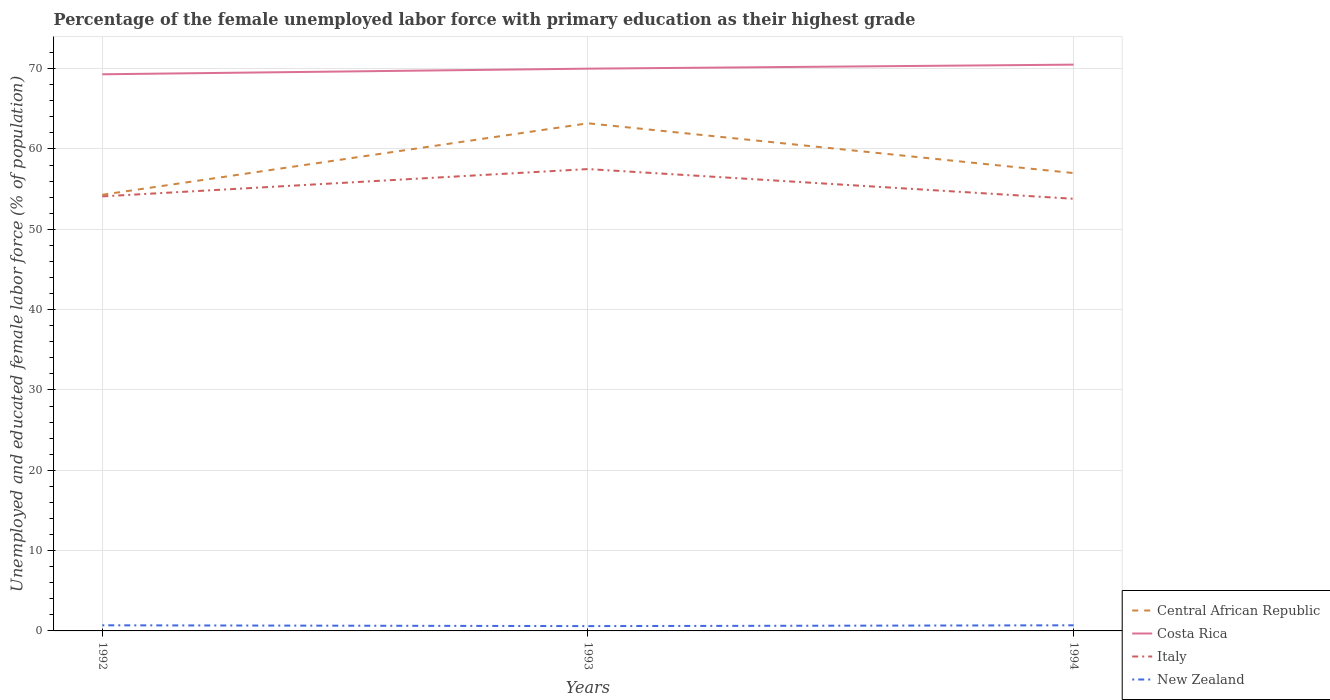How many different coloured lines are there?
Your answer should be very brief. 4. Across all years, what is the maximum percentage of the unemployed female labor force with primary education in Italy?
Your answer should be compact. 53.8. What is the total percentage of the unemployed female labor force with primary education in New Zealand in the graph?
Your answer should be very brief. -0.1. What is the difference between the highest and the second highest percentage of the unemployed female labor force with primary education in Central African Republic?
Your answer should be very brief. 8.9. Is the percentage of the unemployed female labor force with primary education in Central African Republic strictly greater than the percentage of the unemployed female labor force with primary education in New Zealand over the years?
Give a very brief answer. No. How many lines are there?
Your response must be concise. 4. Are the values on the major ticks of Y-axis written in scientific E-notation?
Your answer should be very brief. No. Does the graph contain any zero values?
Provide a short and direct response. No. Where does the legend appear in the graph?
Provide a short and direct response. Bottom right. How many legend labels are there?
Your response must be concise. 4. What is the title of the graph?
Provide a short and direct response. Percentage of the female unemployed labor force with primary education as their highest grade. Does "South Asia" appear as one of the legend labels in the graph?
Provide a succinct answer. No. What is the label or title of the Y-axis?
Your answer should be very brief. Unemployed and educated female labor force (% of population). What is the Unemployed and educated female labor force (% of population) in Central African Republic in 1992?
Your answer should be compact. 54.3. What is the Unemployed and educated female labor force (% of population) of Costa Rica in 1992?
Give a very brief answer. 69.3. What is the Unemployed and educated female labor force (% of population) of Italy in 1992?
Keep it short and to the point. 54.1. What is the Unemployed and educated female labor force (% of population) in New Zealand in 1992?
Ensure brevity in your answer.  0.7. What is the Unemployed and educated female labor force (% of population) in Central African Republic in 1993?
Keep it short and to the point. 63.2. What is the Unemployed and educated female labor force (% of population) in Costa Rica in 1993?
Your answer should be compact. 70. What is the Unemployed and educated female labor force (% of population) of Italy in 1993?
Offer a terse response. 57.5. What is the Unemployed and educated female labor force (% of population) of New Zealand in 1993?
Offer a terse response. 0.6. What is the Unemployed and educated female labor force (% of population) of Costa Rica in 1994?
Provide a succinct answer. 70.5. What is the Unemployed and educated female labor force (% of population) of Italy in 1994?
Your answer should be compact. 53.8. What is the Unemployed and educated female labor force (% of population) in New Zealand in 1994?
Your response must be concise. 0.7. Across all years, what is the maximum Unemployed and educated female labor force (% of population) in Central African Republic?
Offer a terse response. 63.2. Across all years, what is the maximum Unemployed and educated female labor force (% of population) of Costa Rica?
Your response must be concise. 70.5. Across all years, what is the maximum Unemployed and educated female labor force (% of population) in Italy?
Provide a succinct answer. 57.5. Across all years, what is the maximum Unemployed and educated female labor force (% of population) in New Zealand?
Your response must be concise. 0.7. Across all years, what is the minimum Unemployed and educated female labor force (% of population) of Central African Republic?
Give a very brief answer. 54.3. Across all years, what is the minimum Unemployed and educated female labor force (% of population) in Costa Rica?
Your answer should be very brief. 69.3. Across all years, what is the minimum Unemployed and educated female labor force (% of population) of Italy?
Give a very brief answer. 53.8. Across all years, what is the minimum Unemployed and educated female labor force (% of population) in New Zealand?
Offer a terse response. 0.6. What is the total Unemployed and educated female labor force (% of population) of Central African Republic in the graph?
Make the answer very short. 174.5. What is the total Unemployed and educated female labor force (% of population) in Costa Rica in the graph?
Your response must be concise. 209.8. What is the total Unemployed and educated female labor force (% of population) in Italy in the graph?
Give a very brief answer. 165.4. What is the difference between the Unemployed and educated female labor force (% of population) in Italy in 1992 and that in 1993?
Give a very brief answer. -3.4. What is the difference between the Unemployed and educated female labor force (% of population) in New Zealand in 1992 and that in 1993?
Offer a terse response. 0.1. What is the difference between the Unemployed and educated female labor force (% of population) in Central African Republic in 1993 and that in 1994?
Your answer should be very brief. 6.2. What is the difference between the Unemployed and educated female labor force (% of population) of Italy in 1993 and that in 1994?
Offer a very short reply. 3.7. What is the difference between the Unemployed and educated female labor force (% of population) in Central African Republic in 1992 and the Unemployed and educated female labor force (% of population) in Costa Rica in 1993?
Provide a succinct answer. -15.7. What is the difference between the Unemployed and educated female labor force (% of population) in Central African Republic in 1992 and the Unemployed and educated female labor force (% of population) in New Zealand in 1993?
Offer a terse response. 53.7. What is the difference between the Unemployed and educated female labor force (% of population) in Costa Rica in 1992 and the Unemployed and educated female labor force (% of population) in New Zealand in 1993?
Ensure brevity in your answer.  68.7. What is the difference between the Unemployed and educated female labor force (% of population) of Italy in 1992 and the Unemployed and educated female labor force (% of population) of New Zealand in 1993?
Keep it short and to the point. 53.5. What is the difference between the Unemployed and educated female labor force (% of population) of Central African Republic in 1992 and the Unemployed and educated female labor force (% of population) of Costa Rica in 1994?
Provide a short and direct response. -16.2. What is the difference between the Unemployed and educated female labor force (% of population) of Central African Republic in 1992 and the Unemployed and educated female labor force (% of population) of New Zealand in 1994?
Provide a succinct answer. 53.6. What is the difference between the Unemployed and educated female labor force (% of population) in Costa Rica in 1992 and the Unemployed and educated female labor force (% of population) in New Zealand in 1994?
Provide a succinct answer. 68.6. What is the difference between the Unemployed and educated female labor force (% of population) of Italy in 1992 and the Unemployed and educated female labor force (% of population) of New Zealand in 1994?
Your answer should be very brief. 53.4. What is the difference between the Unemployed and educated female labor force (% of population) of Central African Republic in 1993 and the Unemployed and educated female labor force (% of population) of Costa Rica in 1994?
Provide a short and direct response. -7.3. What is the difference between the Unemployed and educated female labor force (% of population) in Central African Republic in 1993 and the Unemployed and educated female labor force (% of population) in New Zealand in 1994?
Provide a succinct answer. 62.5. What is the difference between the Unemployed and educated female labor force (% of population) of Costa Rica in 1993 and the Unemployed and educated female labor force (% of population) of Italy in 1994?
Your answer should be compact. 16.2. What is the difference between the Unemployed and educated female labor force (% of population) of Costa Rica in 1993 and the Unemployed and educated female labor force (% of population) of New Zealand in 1994?
Offer a very short reply. 69.3. What is the difference between the Unemployed and educated female labor force (% of population) of Italy in 1993 and the Unemployed and educated female labor force (% of population) of New Zealand in 1994?
Your answer should be very brief. 56.8. What is the average Unemployed and educated female labor force (% of population) of Central African Republic per year?
Give a very brief answer. 58.17. What is the average Unemployed and educated female labor force (% of population) in Costa Rica per year?
Provide a succinct answer. 69.93. What is the average Unemployed and educated female labor force (% of population) in Italy per year?
Provide a short and direct response. 55.13. In the year 1992, what is the difference between the Unemployed and educated female labor force (% of population) of Central African Republic and Unemployed and educated female labor force (% of population) of New Zealand?
Offer a very short reply. 53.6. In the year 1992, what is the difference between the Unemployed and educated female labor force (% of population) in Costa Rica and Unemployed and educated female labor force (% of population) in Italy?
Ensure brevity in your answer.  15.2. In the year 1992, what is the difference between the Unemployed and educated female labor force (% of population) in Costa Rica and Unemployed and educated female labor force (% of population) in New Zealand?
Keep it short and to the point. 68.6. In the year 1992, what is the difference between the Unemployed and educated female labor force (% of population) in Italy and Unemployed and educated female labor force (% of population) in New Zealand?
Give a very brief answer. 53.4. In the year 1993, what is the difference between the Unemployed and educated female labor force (% of population) in Central African Republic and Unemployed and educated female labor force (% of population) in Costa Rica?
Offer a terse response. -6.8. In the year 1993, what is the difference between the Unemployed and educated female labor force (% of population) in Central African Republic and Unemployed and educated female labor force (% of population) in New Zealand?
Provide a short and direct response. 62.6. In the year 1993, what is the difference between the Unemployed and educated female labor force (% of population) of Costa Rica and Unemployed and educated female labor force (% of population) of Italy?
Provide a succinct answer. 12.5. In the year 1993, what is the difference between the Unemployed and educated female labor force (% of population) of Costa Rica and Unemployed and educated female labor force (% of population) of New Zealand?
Your answer should be very brief. 69.4. In the year 1993, what is the difference between the Unemployed and educated female labor force (% of population) in Italy and Unemployed and educated female labor force (% of population) in New Zealand?
Keep it short and to the point. 56.9. In the year 1994, what is the difference between the Unemployed and educated female labor force (% of population) in Central African Republic and Unemployed and educated female labor force (% of population) in Costa Rica?
Make the answer very short. -13.5. In the year 1994, what is the difference between the Unemployed and educated female labor force (% of population) in Central African Republic and Unemployed and educated female labor force (% of population) in New Zealand?
Your answer should be very brief. 56.3. In the year 1994, what is the difference between the Unemployed and educated female labor force (% of population) in Costa Rica and Unemployed and educated female labor force (% of population) in Italy?
Your response must be concise. 16.7. In the year 1994, what is the difference between the Unemployed and educated female labor force (% of population) in Costa Rica and Unemployed and educated female labor force (% of population) in New Zealand?
Give a very brief answer. 69.8. In the year 1994, what is the difference between the Unemployed and educated female labor force (% of population) in Italy and Unemployed and educated female labor force (% of population) in New Zealand?
Provide a short and direct response. 53.1. What is the ratio of the Unemployed and educated female labor force (% of population) in Central African Republic in 1992 to that in 1993?
Provide a short and direct response. 0.86. What is the ratio of the Unemployed and educated female labor force (% of population) in Costa Rica in 1992 to that in 1993?
Provide a short and direct response. 0.99. What is the ratio of the Unemployed and educated female labor force (% of population) in Italy in 1992 to that in 1993?
Keep it short and to the point. 0.94. What is the ratio of the Unemployed and educated female labor force (% of population) of New Zealand in 1992 to that in 1993?
Keep it short and to the point. 1.17. What is the ratio of the Unemployed and educated female labor force (% of population) in Central African Republic in 1992 to that in 1994?
Your answer should be compact. 0.95. What is the ratio of the Unemployed and educated female labor force (% of population) in Costa Rica in 1992 to that in 1994?
Your answer should be very brief. 0.98. What is the ratio of the Unemployed and educated female labor force (% of population) of Italy in 1992 to that in 1994?
Your answer should be very brief. 1.01. What is the ratio of the Unemployed and educated female labor force (% of population) of Central African Republic in 1993 to that in 1994?
Ensure brevity in your answer.  1.11. What is the ratio of the Unemployed and educated female labor force (% of population) of Costa Rica in 1993 to that in 1994?
Offer a terse response. 0.99. What is the ratio of the Unemployed and educated female labor force (% of population) of Italy in 1993 to that in 1994?
Keep it short and to the point. 1.07. What is the ratio of the Unemployed and educated female labor force (% of population) of New Zealand in 1993 to that in 1994?
Provide a succinct answer. 0.86. What is the difference between the highest and the second highest Unemployed and educated female labor force (% of population) in Costa Rica?
Offer a terse response. 0.5. What is the difference between the highest and the second highest Unemployed and educated female labor force (% of population) in Italy?
Give a very brief answer. 3.4. What is the difference between the highest and the lowest Unemployed and educated female labor force (% of population) of Central African Republic?
Keep it short and to the point. 8.9. What is the difference between the highest and the lowest Unemployed and educated female labor force (% of population) of Costa Rica?
Ensure brevity in your answer.  1.2. What is the difference between the highest and the lowest Unemployed and educated female labor force (% of population) of Italy?
Your answer should be compact. 3.7. 